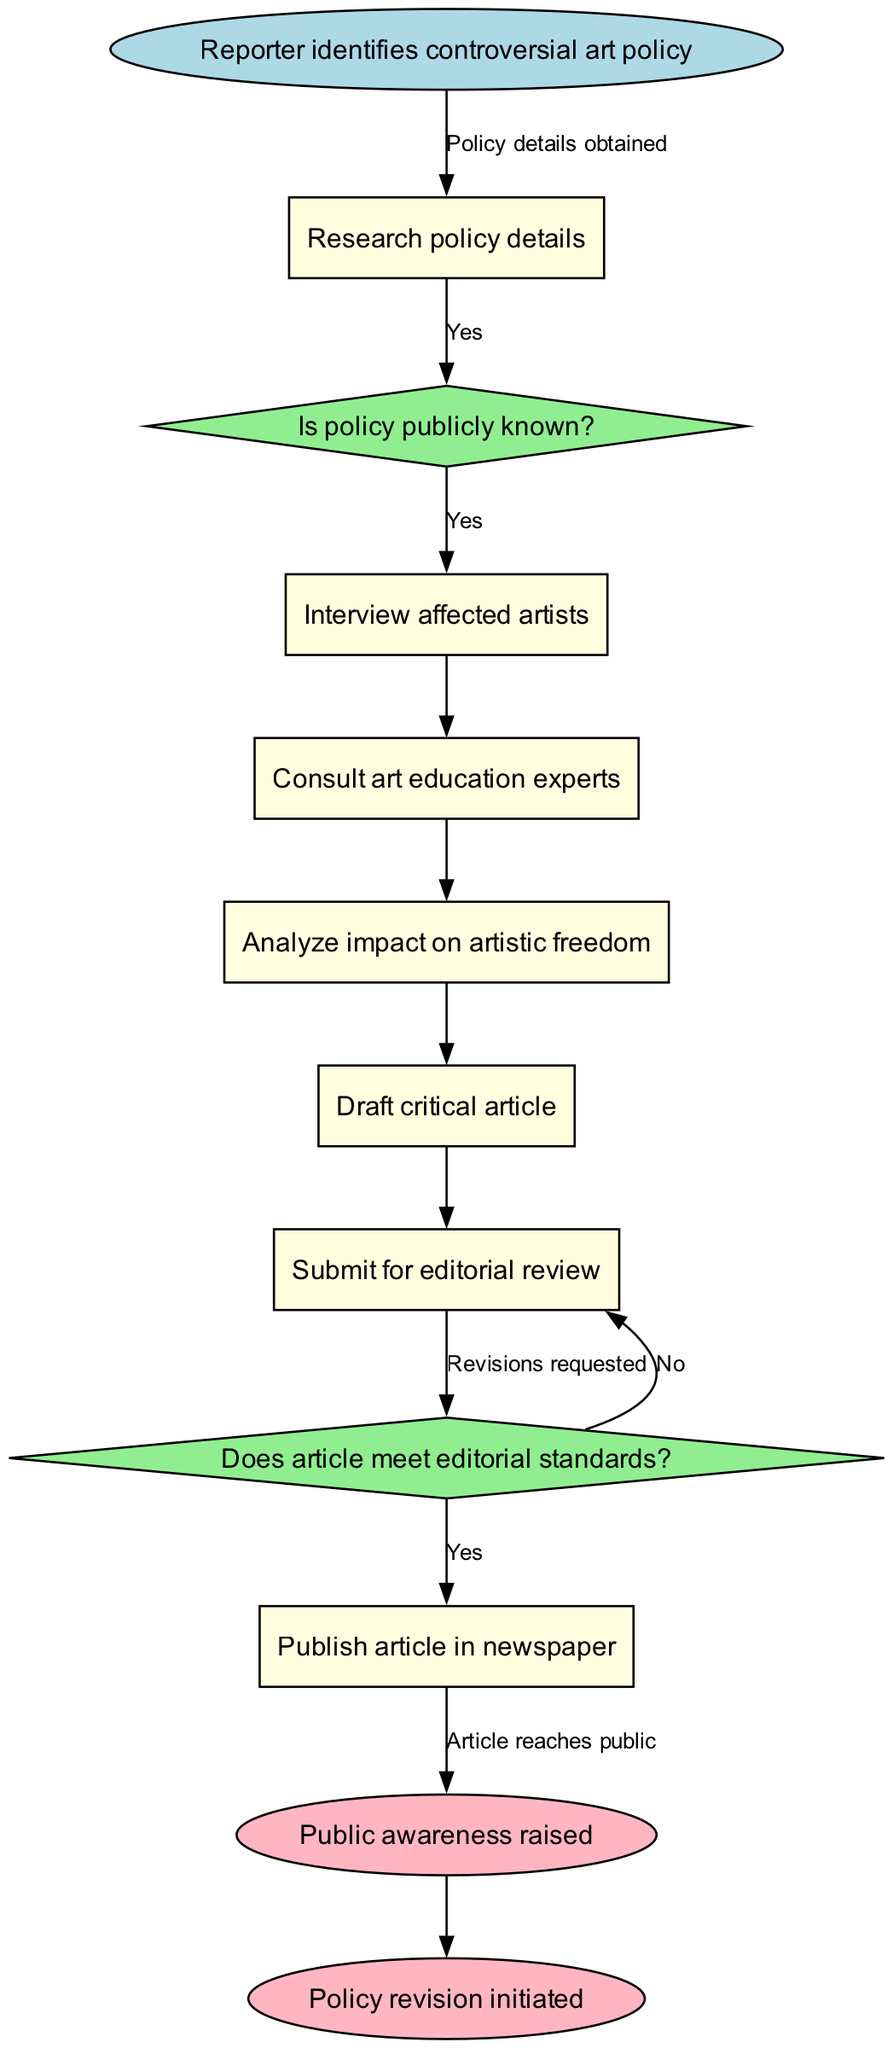What is the starting event of the pathway? The starting event is the first node in the diagram, which indicates the initiation of the process. Here, it is denoted as "Reporter identifies controversial art policy."
Answer: Reporter identifies controversial art policy How many tasks are defined in the diagram? To determine the number of tasks, count the individual task nodes in the diagram. There are six tasks listed.
Answer: 6 What is the last task before the editorial review? Identify the task that directly precedes the editorial review. The last task before submitting for editorial review is "Draft critical article."
Answer: Draft critical article What happens if the article does not meet editorial standards? The gateway labeled "Does article meet editorial standards?" leads to two outcomes, and if the answer is "No," it loops back to the task "Draft critical article."
Answer: Article draft completed Which task follows the consultation of art education experts? In the diagram, tasks are sequentially connected. The task that follows "Consult art education experts" is "Analyze impact on artistic freedom."
Answer: Analyze impact on artistic freedom How many end events are present in the diagram? Count the end event nodes available in the diagram, which represent the final outcomes. There are two end events listed.
Answer: 2 What is the second gateway in the pathway? The gateways are decision points represented in diamond shapes. The second gateway is "Does article meet editorial standards?"
Answer: Does article meet editorial standards? What is the outcome if the policy is publicly known? If the policy is publicly known, the pathway indicates the reporter can directly proceed by interviewing affected artists.
Answer: Interview affected artists What does the pathway aim to achieve? The diagram concludes with two specific outcomes, and the primary aim is to raise public awareness and initiate policy revision.
Answer: Public awareness raised and Policy revision initiated 